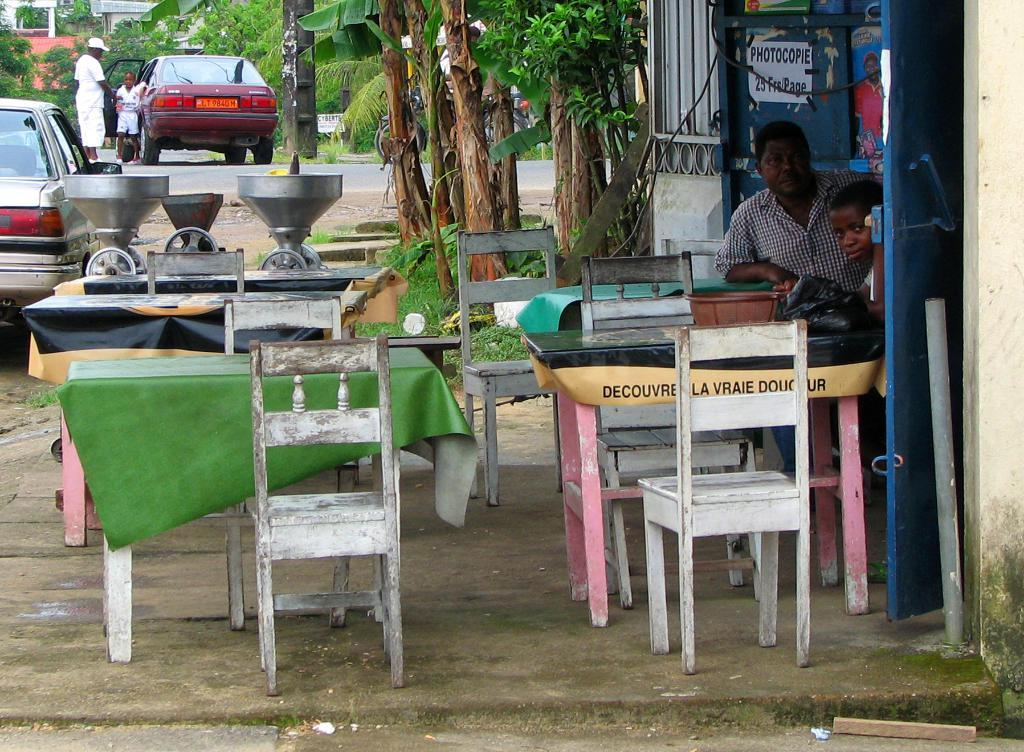What type of furniture can be seen in the image? There are tables and chairs in the image. Where are the chairs located in relation to the tables? The chairs are on the ground in the image. What is the man in the image doing? A man is sitting in the image. What can be seen in the background of the image? Cars are visible on the road in the image. What idea does the man have while sitting on the chair in the image? There is no indication of the man's thoughts or ideas in the image, so it cannot be determined. How does the man grip the chair in the image? The image does not show the man's hands or how he is gripping the chair, so it cannot be determined. 